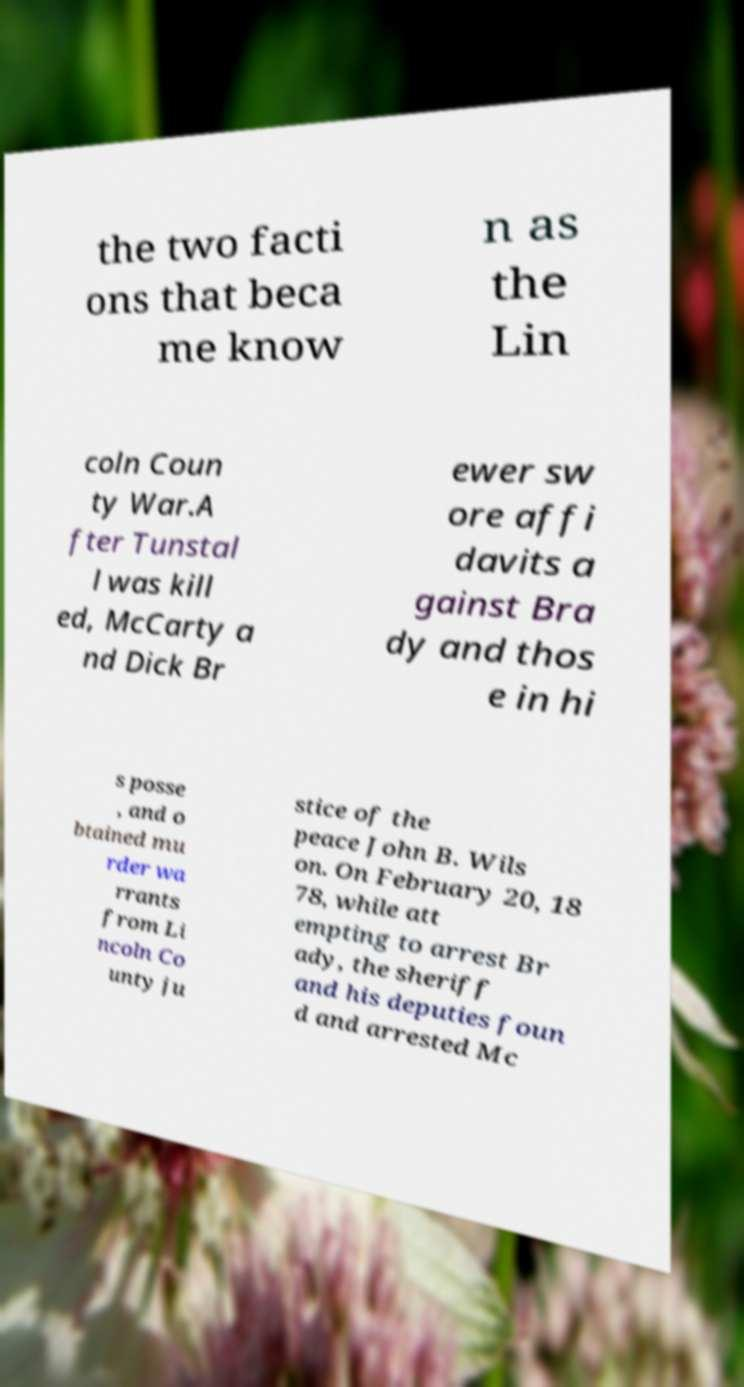There's text embedded in this image that I need extracted. Can you transcribe it verbatim? the two facti ons that beca me know n as the Lin coln Coun ty War.A fter Tunstal l was kill ed, McCarty a nd Dick Br ewer sw ore affi davits a gainst Bra dy and thos e in hi s posse , and o btained mu rder wa rrants from Li ncoln Co unty ju stice of the peace John B. Wils on. On February 20, 18 78, while att empting to arrest Br ady, the sheriff and his deputies foun d and arrested Mc 